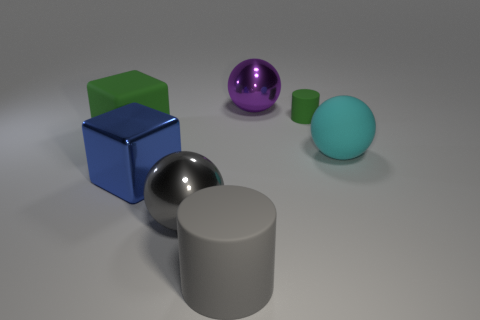Subtract all blue balls. Subtract all yellow cylinders. How many balls are left? 3 Add 2 big rubber things. How many objects exist? 9 Subtract all cylinders. How many objects are left? 5 Add 4 green rubber cylinders. How many green rubber cylinders are left? 5 Add 4 large cyan matte spheres. How many large cyan matte spheres exist? 5 Subtract 0 yellow cylinders. How many objects are left? 7 Subtract all big matte blocks. Subtract all big purple metallic objects. How many objects are left? 5 